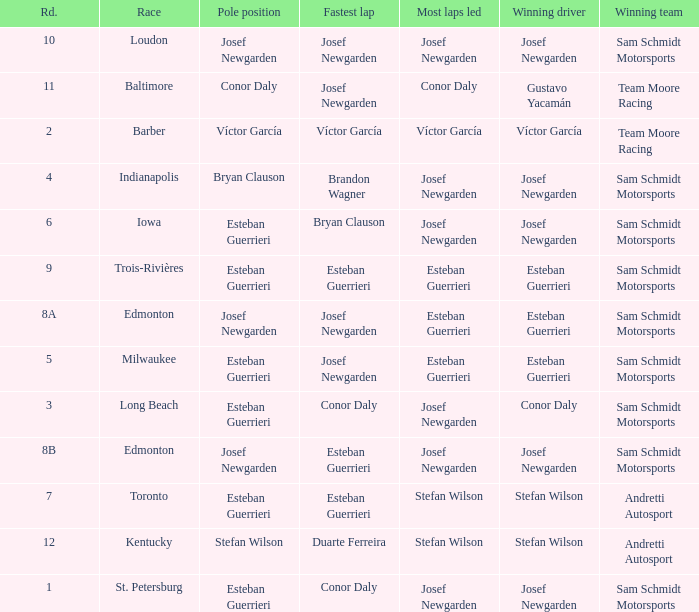Who had the fastest lap(s) when stefan wilson had the pole? Duarte Ferreira. 